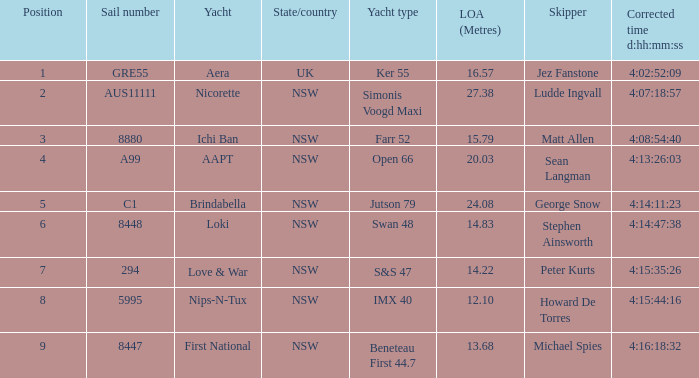What is the number of the sail with an overall length of 13.68? 8447.0. 